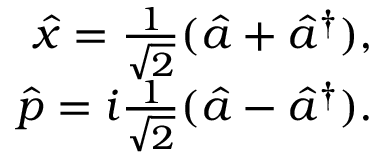Convert formula to latex. <formula><loc_0><loc_0><loc_500><loc_500>\begin{array} { r } { \hat { x } = \frac { 1 } { \sqrt { 2 } } ( \hat { a } + \hat { a } ^ { \dagger } ) , } \\ { \hat { p } = i \frac { 1 } { \sqrt { 2 } } ( \hat { a } - \hat { a } ^ { \dagger } ) . } \end{array}</formula> 